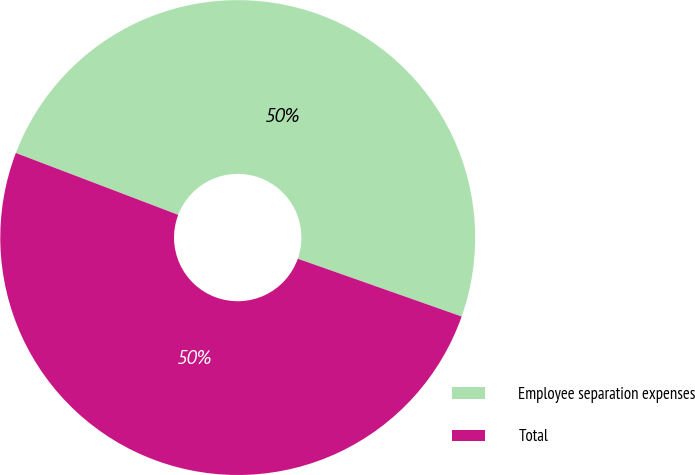<chart> <loc_0><loc_0><loc_500><loc_500><pie_chart><fcel>Employee separation expenses<fcel>Total<nl><fcel>49.6%<fcel>50.4%<nl></chart> 